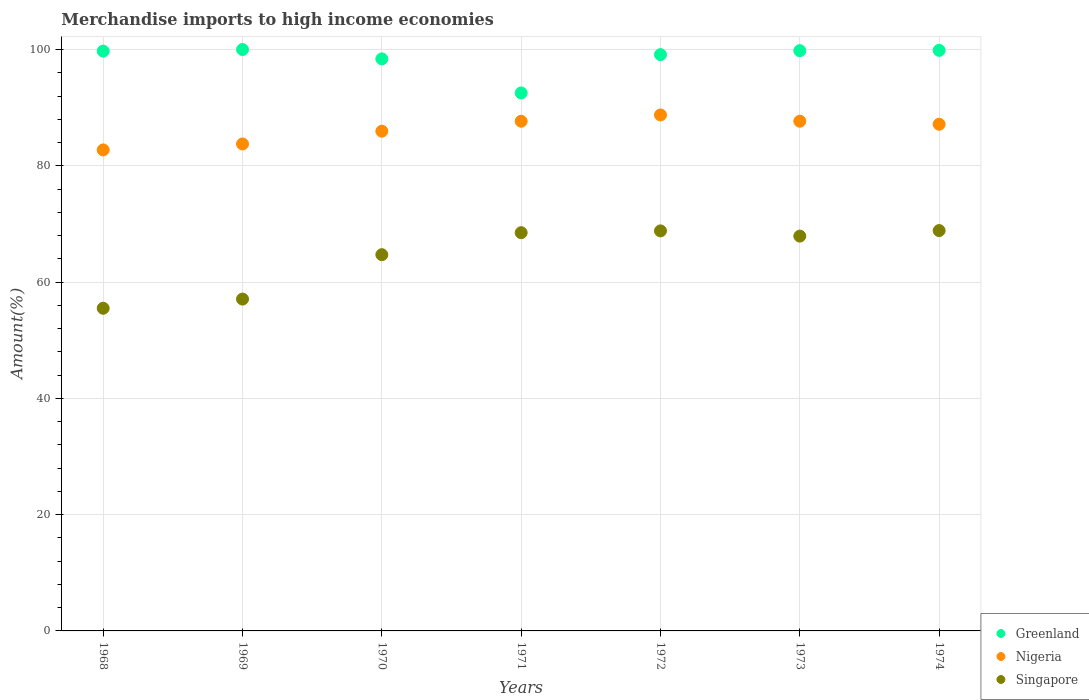What is the percentage of amount earned from merchandise imports in Singapore in 1968?
Your answer should be very brief. 55.49. Across all years, what is the maximum percentage of amount earned from merchandise imports in Singapore?
Your answer should be very brief. 68.86. Across all years, what is the minimum percentage of amount earned from merchandise imports in Greenland?
Offer a very short reply. 92.54. In which year was the percentage of amount earned from merchandise imports in Nigeria maximum?
Keep it short and to the point. 1972. In which year was the percentage of amount earned from merchandise imports in Singapore minimum?
Your response must be concise. 1968. What is the total percentage of amount earned from merchandise imports in Greenland in the graph?
Your response must be concise. 689.44. What is the difference between the percentage of amount earned from merchandise imports in Nigeria in 1970 and that in 1972?
Your answer should be compact. -2.79. What is the difference between the percentage of amount earned from merchandise imports in Nigeria in 1973 and the percentage of amount earned from merchandise imports in Greenland in 1970?
Offer a terse response. -10.72. What is the average percentage of amount earned from merchandise imports in Greenland per year?
Your answer should be very brief. 98.49. In the year 1974, what is the difference between the percentage of amount earned from merchandise imports in Singapore and percentage of amount earned from merchandise imports in Greenland?
Provide a short and direct response. -31. What is the ratio of the percentage of amount earned from merchandise imports in Nigeria in 1969 to that in 1974?
Your answer should be very brief. 0.96. Is the percentage of amount earned from merchandise imports in Nigeria in 1971 less than that in 1972?
Your answer should be very brief. Yes. What is the difference between the highest and the second highest percentage of amount earned from merchandise imports in Greenland?
Ensure brevity in your answer.  0.14. What is the difference between the highest and the lowest percentage of amount earned from merchandise imports in Greenland?
Keep it short and to the point. 7.46. In how many years, is the percentage of amount earned from merchandise imports in Nigeria greater than the average percentage of amount earned from merchandise imports in Nigeria taken over all years?
Your answer should be compact. 4. Is the sum of the percentage of amount earned from merchandise imports in Greenland in 1968 and 1970 greater than the maximum percentage of amount earned from merchandise imports in Singapore across all years?
Give a very brief answer. Yes. Is it the case that in every year, the sum of the percentage of amount earned from merchandise imports in Nigeria and percentage of amount earned from merchandise imports in Greenland  is greater than the percentage of amount earned from merchandise imports in Singapore?
Provide a succinct answer. Yes. Does the percentage of amount earned from merchandise imports in Greenland monotonically increase over the years?
Give a very brief answer. No. What is the difference between two consecutive major ticks on the Y-axis?
Your response must be concise. 20. Does the graph contain grids?
Provide a succinct answer. Yes. How many legend labels are there?
Give a very brief answer. 3. How are the legend labels stacked?
Your response must be concise. Vertical. What is the title of the graph?
Provide a succinct answer. Merchandise imports to high income economies. Does "Tajikistan" appear as one of the legend labels in the graph?
Your answer should be very brief. No. What is the label or title of the Y-axis?
Your answer should be compact. Amount(%). What is the Amount(%) in Greenland in 1968?
Keep it short and to the point. 99.73. What is the Amount(%) of Nigeria in 1968?
Your response must be concise. 82.73. What is the Amount(%) of Singapore in 1968?
Provide a short and direct response. 55.49. What is the Amount(%) in Nigeria in 1969?
Offer a terse response. 83.76. What is the Amount(%) in Singapore in 1969?
Provide a short and direct response. 57.08. What is the Amount(%) in Greenland in 1970?
Provide a short and direct response. 98.39. What is the Amount(%) in Nigeria in 1970?
Offer a terse response. 85.95. What is the Amount(%) of Singapore in 1970?
Offer a terse response. 64.71. What is the Amount(%) of Greenland in 1971?
Provide a succinct answer. 92.54. What is the Amount(%) in Nigeria in 1971?
Ensure brevity in your answer.  87.66. What is the Amount(%) in Singapore in 1971?
Keep it short and to the point. 68.49. What is the Amount(%) of Greenland in 1972?
Your answer should be compact. 99.12. What is the Amount(%) of Nigeria in 1972?
Your answer should be very brief. 88.74. What is the Amount(%) in Singapore in 1972?
Make the answer very short. 68.8. What is the Amount(%) in Greenland in 1973?
Provide a short and direct response. 99.8. What is the Amount(%) in Nigeria in 1973?
Your response must be concise. 87.67. What is the Amount(%) in Singapore in 1973?
Offer a terse response. 67.91. What is the Amount(%) in Greenland in 1974?
Provide a succinct answer. 99.86. What is the Amount(%) in Nigeria in 1974?
Your answer should be very brief. 87.14. What is the Amount(%) of Singapore in 1974?
Your answer should be very brief. 68.86. Across all years, what is the maximum Amount(%) of Greenland?
Offer a very short reply. 100. Across all years, what is the maximum Amount(%) of Nigeria?
Offer a very short reply. 88.74. Across all years, what is the maximum Amount(%) of Singapore?
Provide a short and direct response. 68.86. Across all years, what is the minimum Amount(%) in Greenland?
Your answer should be compact. 92.54. Across all years, what is the minimum Amount(%) of Nigeria?
Your response must be concise. 82.73. Across all years, what is the minimum Amount(%) of Singapore?
Provide a succinct answer. 55.49. What is the total Amount(%) in Greenland in the graph?
Provide a succinct answer. 689.44. What is the total Amount(%) of Nigeria in the graph?
Your answer should be very brief. 603.66. What is the total Amount(%) of Singapore in the graph?
Your answer should be very brief. 451.34. What is the difference between the Amount(%) in Greenland in 1968 and that in 1969?
Make the answer very short. -0.27. What is the difference between the Amount(%) in Nigeria in 1968 and that in 1969?
Offer a very short reply. -1.02. What is the difference between the Amount(%) in Singapore in 1968 and that in 1969?
Offer a terse response. -1.58. What is the difference between the Amount(%) of Greenland in 1968 and that in 1970?
Offer a terse response. 1.33. What is the difference between the Amount(%) in Nigeria in 1968 and that in 1970?
Provide a succinct answer. -3.22. What is the difference between the Amount(%) of Singapore in 1968 and that in 1970?
Your response must be concise. -9.22. What is the difference between the Amount(%) in Greenland in 1968 and that in 1971?
Make the answer very short. 7.19. What is the difference between the Amount(%) of Nigeria in 1968 and that in 1971?
Give a very brief answer. -4.93. What is the difference between the Amount(%) of Singapore in 1968 and that in 1971?
Your answer should be very brief. -13. What is the difference between the Amount(%) of Greenland in 1968 and that in 1972?
Provide a short and direct response. 0.6. What is the difference between the Amount(%) of Nigeria in 1968 and that in 1972?
Provide a short and direct response. -6.01. What is the difference between the Amount(%) in Singapore in 1968 and that in 1972?
Offer a very short reply. -13.31. What is the difference between the Amount(%) of Greenland in 1968 and that in 1973?
Your answer should be very brief. -0.08. What is the difference between the Amount(%) of Nigeria in 1968 and that in 1973?
Keep it short and to the point. -4.94. What is the difference between the Amount(%) of Singapore in 1968 and that in 1973?
Ensure brevity in your answer.  -12.41. What is the difference between the Amount(%) of Greenland in 1968 and that in 1974?
Ensure brevity in your answer.  -0.13. What is the difference between the Amount(%) of Nigeria in 1968 and that in 1974?
Keep it short and to the point. -4.41. What is the difference between the Amount(%) of Singapore in 1968 and that in 1974?
Make the answer very short. -13.36. What is the difference between the Amount(%) of Greenland in 1969 and that in 1970?
Your answer should be compact. 1.61. What is the difference between the Amount(%) in Nigeria in 1969 and that in 1970?
Provide a short and direct response. -2.2. What is the difference between the Amount(%) in Singapore in 1969 and that in 1970?
Ensure brevity in your answer.  -7.64. What is the difference between the Amount(%) in Greenland in 1969 and that in 1971?
Ensure brevity in your answer.  7.46. What is the difference between the Amount(%) of Nigeria in 1969 and that in 1971?
Your answer should be very brief. -3.91. What is the difference between the Amount(%) of Singapore in 1969 and that in 1971?
Keep it short and to the point. -11.42. What is the difference between the Amount(%) in Greenland in 1969 and that in 1972?
Ensure brevity in your answer.  0.88. What is the difference between the Amount(%) of Nigeria in 1969 and that in 1972?
Offer a terse response. -4.99. What is the difference between the Amount(%) in Singapore in 1969 and that in 1972?
Your answer should be compact. -11.73. What is the difference between the Amount(%) of Greenland in 1969 and that in 1973?
Offer a very short reply. 0.2. What is the difference between the Amount(%) in Nigeria in 1969 and that in 1973?
Your response must be concise. -3.91. What is the difference between the Amount(%) of Singapore in 1969 and that in 1973?
Give a very brief answer. -10.83. What is the difference between the Amount(%) of Greenland in 1969 and that in 1974?
Offer a terse response. 0.14. What is the difference between the Amount(%) of Nigeria in 1969 and that in 1974?
Keep it short and to the point. -3.39. What is the difference between the Amount(%) of Singapore in 1969 and that in 1974?
Keep it short and to the point. -11.78. What is the difference between the Amount(%) in Greenland in 1970 and that in 1971?
Give a very brief answer. 5.86. What is the difference between the Amount(%) of Nigeria in 1970 and that in 1971?
Your response must be concise. -1.71. What is the difference between the Amount(%) in Singapore in 1970 and that in 1971?
Offer a very short reply. -3.78. What is the difference between the Amount(%) of Greenland in 1970 and that in 1972?
Provide a succinct answer. -0.73. What is the difference between the Amount(%) of Nigeria in 1970 and that in 1972?
Your response must be concise. -2.79. What is the difference between the Amount(%) in Singapore in 1970 and that in 1972?
Provide a short and direct response. -4.09. What is the difference between the Amount(%) in Greenland in 1970 and that in 1973?
Your response must be concise. -1.41. What is the difference between the Amount(%) of Nigeria in 1970 and that in 1973?
Your response must be concise. -1.71. What is the difference between the Amount(%) of Singapore in 1970 and that in 1973?
Offer a very short reply. -3.2. What is the difference between the Amount(%) of Greenland in 1970 and that in 1974?
Ensure brevity in your answer.  -1.47. What is the difference between the Amount(%) of Nigeria in 1970 and that in 1974?
Make the answer very short. -1.19. What is the difference between the Amount(%) of Singapore in 1970 and that in 1974?
Ensure brevity in your answer.  -4.14. What is the difference between the Amount(%) in Greenland in 1971 and that in 1972?
Provide a short and direct response. -6.59. What is the difference between the Amount(%) of Nigeria in 1971 and that in 1972?
Offer a very short reply. -1.08. What is the difference between the Amount(%) in Singapore in 1971 and that in 1972?
Make the answer very short. -0.31. What is the difference between the Amount(%) in Greenland in 1971 and that in 1973?
Your answer should be very brief. -7.27. What is the difference between the Amount(%) in Nigeria in 1971 and that in 1973?
Ensure brevity in your answer.  -0.01. What is the difference between the Amount(%) in Singapore in 1971 and that in 1973?
Keep it short and to the point. 0.59. What is the difference between the Amount(%) of Greenland in 1971 and that in 1974?
Offer a very short reply. -7.32. What is the difference between the Amount(%) in Nigeria in 1971 and that in 1974?
Make the answer very short. 0.52. What is the difference between the Amount(%) in Singapore in 1971 and that in 1974?
Provide a succinct answer. -0.36. What is the difference between the Amount(%) in Greenland in 1972 and that in 1973?
Your answer should be very brief. -0.68. What is the difference between the Amount(%) of Nigeria in 1972 and that in 1973?
Your answer should be very brief. 1.07. What is the difference between the Amount(%) in Singapore in 1972 and that in 1973?
Offer a terse response. 0.9. What is the difference between the Amount(%) in Greenland in 1972 and that in 1974?
Your answer should be compact. -0.73. What is the difference between the Amount(%) in Nigeria in 1972 and that in 1974?
Keep it short and to the point. 1.6. What is the difference between the Amount(%) in Singapore in 1972 and that in 1974?
Provide a succinct answer. -0.05. What is the difference between the Amount(%) of Greenland in 1973 and that in 1974?
Make the answer very short. -0.05. What is the difference between the Amount(%) in Nigeria in 1973 and that in 1974?
Provide a short and direct response. 0.52. What is the difference between the Amount(%) of Singapore in 1973 and that in 1974?
Offer a terse response. -0.95. What is the difference between the Amount(%) of Greenland in 1968 and the Amount(%) of Nigeria in 1969?
Provide a short and direct response. 15.97. What is the difference between the Amount(%) of Greenland in 1968 and the Amount(%) of Singapore in 1969?
Keep it short and to the point. 42.65. What is the difference between the Amount(%) of Nigeria in 1968 and the Amount(%) of Singapore in 1969?
Give a very brief answer. 25.66. What is the difference between the Amount(%) of Greenland in 1968 and the Amount(%) of Nigeria in 1970?
Give a very brief answer. 13.77. What is the difference between the Amount(%) of Greenland in 1968 and the Amount(%) of Singapore in 1970?
Give a very brief answer. 35.02. What is the difference between the Amount(%) of Nigeria in 1968 and the Amount(%) of Singapore in 1970?
Keep it short and to the point. 18.02. What is the difference between the Amount(%) of Greenland in 1968 and the Amount(%) of Nigeria in 1971?
Offer a terse response. 12.07. What is the difference between the Amount(%) of Greenland in 1968 and the Amount(%) of Singapore in 1971?
Ensure brevity in your answer.  31.23. What is the difference between the Amount(%) of Nigeria in 1968 and the Amount(%) of Singapore in 1971?
Keep it short and to the point. 14.24. What is the difference between the Amount(%) of Greenland in 1968 and the Amount(%) of Nigeria in 1972?
Your response must be concise. 10.98. What is the difference between the Amount(%) in Greenland in 1968 and the Amount(%) in Singapore in 1972?
Keep it short and to the point. 30.92. What is the difference between the Amount(%) of Nigeria in 1968 and the Amount(%) of Singapore in 1972?
Your answer should be very brief. 13.93. What is the difference between the Amount(%) in Greenland in 1968 and the Amount(%) in Nigeria in 1973?
Give a very brief answer. 12.06. What is the difference between the Amount(%) in Greenland in 1968 and the Amount(%) in Singapore in 1973?
Ensure brevity in your answer.  31.82. What is the difference between the Amount(%) of Nigeria in 1968 and the Amount(%) of Singapore in 1973?
Your answer should be very brief. 14.82. What is the difference between the Amount(%) of Greenland in 1968 and the Amount(%) of Nigeria in 1974?
Ensure brevity in your answer.  12.58. What is the difference between the Amount(%) of Greenland in 1968 and the Amount(%) of Singapore in 1974?
Your response must be concise. 30.87. What is the difference between the Amount(%) of Nigeria in 1968 and the Amount(%) of Singapore in 1974?
Offer a terse response. 13.87. What is the difference between the Amount(%) of Greenland in 1969 and the Amount(%) of Nigeria in 1970?
Provide a short and direct response. 14.05. What is the difference between the Amount(%) in Greenland in 1969 and the Amount(%) in Singapore in 1970?
Ensure brevity in your answer.  35.29. What is the difference between the Amount(%) of Nigeria in 1969 and the Amount(%) of Singapore in 1970?
Offer a very short reply. 19.04. What is the difference between the Amount(%) in Greenland in 1969 and the Amount(%) in Nigeria in 1971?
Keep it short and to the point. 12.34. What is the difference between the Amount(%) of Greenland in 1969 and the Amount(%) of Singapore in 1971?
Provide a succinct answer. 31.51. What is the difference between the Amount(%) in Nigeria in 1969 and the Amount(%) in Singapore in 1971?
Your response must be concise. 15.26. What is the difference between the Amount(%) of Greenland in 1969 and the Amount(%) of Nigeria in 1972?
Offer a terse response. 11.26. What is the difference between the Amount(%) in Greenland in 1969 and the Amount(%) in Singapore in 1972?
Ensure brevity in your answer.  31.2. What is the difference between the Amount(%) in Nigeria in 1969 and the Amount(%) in Singapore in 1972?
Provide a succinct answer. 14.95. What is the difference between the Amount(%) of Greenland in 1969 and the Amount(%) of Nigeria in 1973?
Provide a succinct answer. 12.33. What is the difference between the Amount(%) of Greenland in 1969 and the Amount(%) of Singapore in 1973?
Offer a terse response. 32.09. What is the difference between the Amount(%) in Nigeria in 1969 and the Amount(%) in Singapore in 1973?
Your response must be concise. 15.85. What is the difference between the Amount(%) in Greenland in 1969 and the Amount(%) in Nigeria in 1974?
Provide a short and direct response. 12.86. What is the difference between the Amount(%) of Greenland in 1969 and the Amount(%) of Singapore in 1974?
Your answer should be compact. 31.14. What is the difference between the Amount(%) in Nigeria in 1969 and the Amount(%) in Singapore in 1974?
Make the answer very short. 14.9. What is the difference between the Amount(%) in Greenland in 1970 and the Amount(%) in Nigeria in 1971?
Make the answer very short. 10.73. What is the difference between the Amount(%) of Greenland in 1970 and the Amount(%) of Singapore in 1971?
Your response must be concise. 29.9. What is the difference between the Amount(%) of Nigeria in 1970 and the Amount(%) of Singapore in 1971?
Give a very brief answer. 17.46. What is the difference between the Amount(%) in Greenland in 1970 and the Amount(%) in Nigeria in 1972?
Your answer should be very brief. 9.65. What is the difference between the Amount(%) in Greenland in 1970 and the Amount(%) in Singapore in 1972?
Provide a succinct answer. 29.59. What is the difference between the Amount(%) in Nigeria in 1970 and the Amount(%) in Singapore in 1972?
Your response must be concise. 17.15. What is the difference between the Amount(%) of Greenland in 1970 and the Amount(%) of Nigeria in 1973?
Your answer should be very brief. 10.72. What is the difference between the Amount(%) in Greenland in 1970 and the Amount(%) in Singapore in 1973?
Provide a succinct answer. 30.48. What is the difference between the Amount(%) in Nigeria in 1970 and the Amount(%) in Singapore in 1973?
Provide a short and direct response. 18.05. What is the difference between the Amount(%) in Greenland in 1970 and the Amount(%) in Nigeria in 1974?
Provide a succinct answer. 11.25. What is the difference between the Amount(%) of Greenland in 1970 and the Amount(%) of Singapore in 1974?
Your answer should be compact. 29.54. What is the difference between the Amount(%) in Nigeria in 1970 and the Amount(%) in Singapore in 1974?
Give a very brief answer. 17.1. What is the difference between the Amount(%) of Greenland in 1971 and the Amount(%) of Nigeria in 1972?
Offer a terse response. 3.79. What is the difference between the Amount(%) in Greenland in 1971 and the Amount(%) in Singapore in 1972?
Your answer should be compact. 23.73. What is the difference between the Amount(%) of Nigeria in 1971 and the Amount(%) of Singapore in 1972?
Offer a terse response. 18.86. What is the difference between the Amount(%) in Greenland in 1971 and the Amount(%) in Nigeria in 1973?
Keep it short and to the point. 4.87. What is the difference between the Amount(%) of Greenland in 1971 and the Amount(%) of Singapore in 1973?
Offer a terse response. 24.63. What is the difference between the Amount(%) of Nigeria in 1971 and the Amount(%) of Singapore in 1973?
Your answer should be compact. 19.75. What is the difference between the Amount(%) in Greenland in 1971 and the Amount(%) in Nigeria in 1974?
Make the answer very short. 5.39. What is the difference between the Amount(%) of Greenland in 1971 and the Amount(%) of Singapore in 1974?
Your response must be concise. 23.68. What is the difference between the Amount(%) of Nigeria in 1971 and the Amount(%) of Singapore in 1974?
Ensure brevity in your answer.  18.81. What is the difference between the Amount(%) of Greenland in 1972 and the Amount(%) of Nigeria in 1973?
Provide a succinct answer. 11.46. What is the difference between the Amount(%) of Greenland in 1972 and the Amount(%) of Singapore in 1973?
Give a very brief answer. 31.22. What is the difference between the Amount(%) in Nigeria in 1972 and the Amount(%) in Singapore in 1973?
Ensure brevity in your answer.  20.83. What is the difference between the Amount(%) in Greenland in 1972 and the Amount(%) in Nigeria in 1974?
Ensure brevity in your answer.  11.98. What is the difference between the Amount(%) of Greenland in 1972 and the Amount(%) of Singapore in 1974?
Keep it short and to the point. 30.27. What is the difference between the Amount(%) in Nigeria in 1972 and the Amount(%) in Singapore in 1974?
Provide a succinct answer. 19.89. What is the difference between the Amount(%) in Greenland in 1973 and the Amount(%) in Nigeria in 1974?
Provide a succinct answer. 12.66. What is the difference between the Amount(%) of Greenland in 1973 and the Amount(%) of Singapore in 1974?
Provide a succinct answer. 30.95. What is the difference between the Amount(%) in Nigeria in 1973 and the Amount(%) in Singapore in 1974?
Your response must be concise. 18.81. What is the average Amount(%) in Greenland per year?
Give a very brief answer. 98.49. What is the average Amount(%) of Nigeria per year?
Keep it short and to the point. 86.24. What is the average Amount(%) of Singapore per year?
Offer a very short reply. 64.48. In the year 1968, what is the difference between the Amount(%) in Greenland and Amount(%) in Nigeria?
Your response must be concise. 17. In the year 1968, what is the difference between the Amount(%) of Greenland and Amount(%) of Singapore?
Keep it short and to the point. 44.23. In the year 1968, what is the difference between the Amount(%) in Nigeria and Amount(%) in Singapore?
Keep it short and to the point. 27.24. In the year 1969, what is the difference between the Amount(%) of Greenland and Amount(%) of Nigeria?
Ensure brevity in your answer.  16.25. In the year 1969, what is the difference between the Amount(%) of Greenland and Amount(%) of Singapore?
Your answer should be very brief. 42.92. In the year 1969, what is the difference between the Amount(%) of Nigeria and Amount(%) of Singapore?
Ensure brevity in your answer.  26.68. In the year 1970, what is the difference between the Amount(%) of Greenland and Amount(%) of Nigeria?
Make the answer very short. 12.44. In the year 1970, what is the difference between the Amount(%) in Greenland and Amount(%) in Singapore?
Make the answer very short. 33.68. In the year 1970, what is the difference between the Amount(%) in Nigeria and Amount(%) in Singapore?
Keep it short and to the point. 21.24. In the year 1971, what is the difference between the Amount(%) in Greenland and Amount(%) in Nigeria?
Ensure brevity in your answer.  4.87. In the year 1971, what is the difference between the Amount(%) of Greenland and Amount(%) of Singapore?
Your response must be concise. 24.04. In the year 1971, what is the difference between the Amount(%) in Nigeria and Amount(%) in Singapore?
Your response must be concise. 19.17. In the year 1972, what is the difference between the Amount(%) of Greenland and Amount(%) of Nigeria?
Your answer should be very brief. 10.38. In the year 1972, what is the difference between the Amount(%) in Greenland and Amount(%) in Singapore?
Make the answer very short. 30.32. In the year 1972, what is the difference between the Amount(%) of Nigeria and Amount(%) of Singapore?
Offer a very short reply. 19.94. In the year 1973, what is the difference between the Amount(%) in Greenland and Amount(%) in Nigeria?
Keep it short and to the point. 12.13. In the year 1973, what is the difference between the Amount(%) in Greenland and Amount(%) in Singapore?
Offer a terse response. 31.9. In the year 1973, what is the difference between the Amount(%) in Nigeria and Amount(%) in Singapore?
Keep it short and to the point. 19.76. In the year 1974, what is the difference between the Amount(%) of Greenland and Amount(%) of Nigeria?
Give a very brief answer. 12.71. In the year 1974, what is the difference between the Amount(%) in Greenland and Amount(%) in Singapore?
Keep it short and to the point. 31. In the year 1974, what is the difference between the Amount(%) in Nigeria and Amount(%) in Singapore?
Ensure brevity in your answer.  18.29. What is the ratio of the Amount(%) in Greenland in 1968 to that in 1969?
Offer a terse response. 1. What is the ratio of the Amount(%) in Nigeria in 1968 to that in 1969?
Your response must be concise. 0.99. What is the ratio of the Amount(%) in Singapore in 1968 to that in 1969?
Make the answer very short. 0.97. What is the ratio of the Amount(%) of Greenland in 1968 to that in 1970?
Offer a very short reply. 1.01. What is the ratio of the Amount(%) in Nigeria in 1968 to that in 1970?
Keep it short and to the point. 0.96. What is the ratio of the Amount(%) of Singapore in 1968 to that in 1970?
Offer a terse response. 0.86. What is the ratio of the Amount(%) in Greenland in 1968 to that in 1971?
Give a very brief answer. 1.08. What is the ratio of the Amount(%) of Nigeria in 1968 to that in 1971?
Provide a short and direct response. 0.94. What is the ratio of the Amount(%) of Singapore in 1968 to that in 1971?
Provide a short and direct response. 0.81. What is the ratio of the Amount(%) of Nigeria in 1968 to that in 1972?
Your answer should be compact. 0.93. What is the ratio of the Amount(%) of Singapore in 1968 to that in 1972?
Give a very brief answer. 0.81. What is the ratio of the Amount(%) in Greenland in 1968 to that in 1973?
Provide a succinct answer. 1. What is the ratio of the Amount(%) in Nigeria in 1968 to that in 1973?
Your answer should be compact. 0.94. What is the ratio of the Amount(%) in Singapore in 1968 to that in 1973?
Offer a very short reply. 0.82. What is the ratio of the Amount(%) in Greenland in 1968 to that in 1974?
Make the answer very short. 1. What is the ratio of the Amount(%) of Nigeria in 1968 to that in 1974?
Provide a short and direct response. 0.95. What is the ratio of the Amount(%) of Singapore in 1968 to that in 1974?
Keep it short and to the point. 0.81. What is the ratio of the Amount(%) of Greenland in 1969 to that in 1970?
Provide a short and direct response. 1.02. What is the ratio of the Amount(%) in Nigeria in 1969 to that in 1970?
Ensure brevity in your answer.  0.97. What is the ratio of the Amount(%) in Singapore in 1969 to that in 1970?
Provide a succinct answer. 0.88. What is the ratio of the Amount(%) in Greenland in 1969 to that in 1971?
Make the answer very short. 1.08. What is the ratio of the Amount(%) in Nigeria in 1969 to that in 1971?
Your response must be concise. 0.96. What is the ratio of the Amount(%) of Greenland in 1969 to that in 1972?
Keep it short and to the point. 1.01. What is the ratio of the Amount(%) in Nigeria in 1969 to that in 1972?
Make the answer very short. 0.94. What is the ratio of the Amount(%) in Singapore in 1969 to that in 1972?
Offer a terse response. 0.83. What is the ratio of the Amount(%) in Greenland in 1969 to that in 1973?
Your response must be concise. 1. What is the ratio of the Amount(%) in Nigeria in 1969 to that in 1973?
Provide a succinct answer. 0.96. What is the ratio of the Amount(%) in Singapore in 1969 to that in 1973?
Give a very brief answer. 0.84. What is the ratio of the Amount(%) of Greenland in 1969 to that in 1974?
Offer a very short reply. 1. What is the ratio of the Amount(%) in Nigeria in 1969 to that in 1974?
Ensure brevity in your answer.  0.96. What is the ratio of the Amount(%) of Singapore in 1969 to that in 1974?
Offer a very short reply. 0.83. What is the ratio of the Amount(%) in Greenland in 1970 to that in 1971?
Make the answer very short. 1.06. What is the ratio of the Amount(%) in Nigeria in 1970 to that in 1971?
Ensure brevity in your answer.  0.98. What is the ratio of the Amount(%) in Singapore in 1970 to that in 1971?
Your response must be concise. 0.94. What is the ratio of the Amount(%) of Greenland in 1970 to that in 1972?
Offer a terse response. 0.99. What is the ratio of the Amount(%) of Nigeria in 1970 to that in 1972?
Your answer should be very brief. 0.97. What is the ratio of the Amount(%) of Singapore in 1970 to that in 1972?
Give a very brief answer. 0.94. What is the ratio of the Amount(%) of Greenland in 1970 to that in 1973?
Provide a short and direct response. 0.99. What is the ratio of the Amount(%) of Nigeria in 1970 to that in 1973?
Offer a very short reply. 0.98. What is the ratio of the Amount(%) of Singapore in 1970 to that in 1973?
Provide a short and direct response. 0.95. What is the ratio of the Amount(%) of Nigeria in 1970 to that in 1974?
Make the answer very short. 0.99. What is the ratio of the Amount(%) in Singapore in 1970 to that in 1974?
Offer a terse response. 0.94. What is the ratio of the Amount(%) in Greenland in 1971 to that in 1972?
Provide a succinct answer. 0.93. What is the ratio of the Amount(%) of Singapore in 1971 to that in 1972?
Offer a very short reply. 1. What is the ratio of the Amount(%) in Greenland in 1971 to that in 1973?
Give a very brief answer. 0.93. What is the ratio of the Amount(%) of Nigeria in 1971 to that in 1973?
Your response must be concise. 1. What is the ratio of the Amount(%) in Singapore in 1971 to that in 1973?
Ensure brevity in your answer.  1.01. What is the ratio of the Amount(%) of Greenland in 1971 to that in 1974?
Keep it short and to the point. 0.93. What is the ratio of the Amount(%) of Nigeria in 1971 to that in 1974?
Keep it short and to the point. 1.01. What is the ratio of the Amount(%) in Singapore in 1971 to that in 1974?
Provide a succinct answer. 0.99. What is the ratio of the Amount(%) of Greenland in 1972 to that in 1973?
Make the answer very short. 0.99. What is the ratio of the Amount(%) of Nigeria in 1972 to that in 1973?
Make the answer very short. 1.01. What is the ratio of the Amount(%) of Singapore in 1972 to that in 1973?
Offer a terse response. 1.01. What is the ratio of the Amount(%) in Nigeria in 1972 to that in 1974?
Your answer should be compact. 1.02. What is the ratio of the Amount(%) of Greenland in 1973 to that in 1974?
Your answer should be compact. 1. What is the ratio of the Amount(%) in Nigeria in 1973 to that in 1974?
Provide a short and direct response. 1.01. What is the ratio of the Amount(%) of Singapore in 1973 to that in 1974?
Make the answer very short. 0.99. What is the difference between the highest and the second highest Amount(%) in Greenland?
Offer a very short reply. 0.14. What is the difference between the highest and the second highest Amount(%) of Nigeria?
Offer a terse response. 1.07. What is the difference between the highest and the second highest Amount(%) in Singapore?
Make the answer very short. 0.05. What is the difference between the highest and the lowest Amount(%) in Greenland?
Make the answer very short. 7.46. What is the difference between the highest and the lowest Amount(%) in Nigeria?
Keep it short and to the point. 6.01. What is the difference between the highest and the lowest Amount(%) of Singapore?
Offer a very short reply. 13.36. 